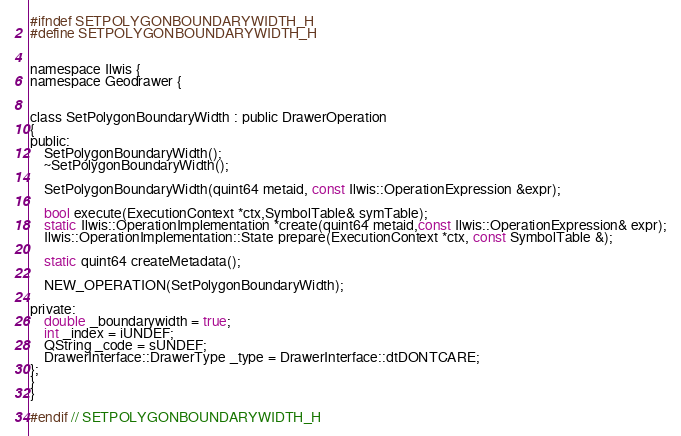Convert code to text. <code><loc_0><loc_0><loc_500><loc_500><_C_>#ifndef SETPOLYGONBOUNDARYWIDTH_H
#define SETPOLYGONBOUNDARYWIDTH_H


namespace Ilwis {
namespace Geodrawer {


class SetPolygonBoundaryWidth : public DrawerOperation
{
public:
    SetPolygonBoundaryWidth();
    ~SetPolygonBoundaryWidth();

    SetPolygonBoundaryWidth(quint64 metaid, const Ilwis::OperationExpression &expr);

    bool execute(ExecutionContext *ctx,SymbolTable& symTable);
    static Ilwis::OperationImplementation *create(quint64 metaid,const Ilwis::OperationExpression& expr);
    Ilwis::OperationImplementation::State prepare(ExecutionContext *ctx, const SymbolTable &);

    static quint64 createMetadata();

    NEW_OPERATION(SetPolygonBoundaryWidth);

private:
    double _boundarywidth = true;
    int _index = iUNDEF;
    QString _code = sUNDEF;
    DrawerInterface::DrawerType _type = DrawerInterface::dtDONTCARE;
};
}
}

#endif // SETPOLYGONBOUNDARYWIDTH_H
</code> 